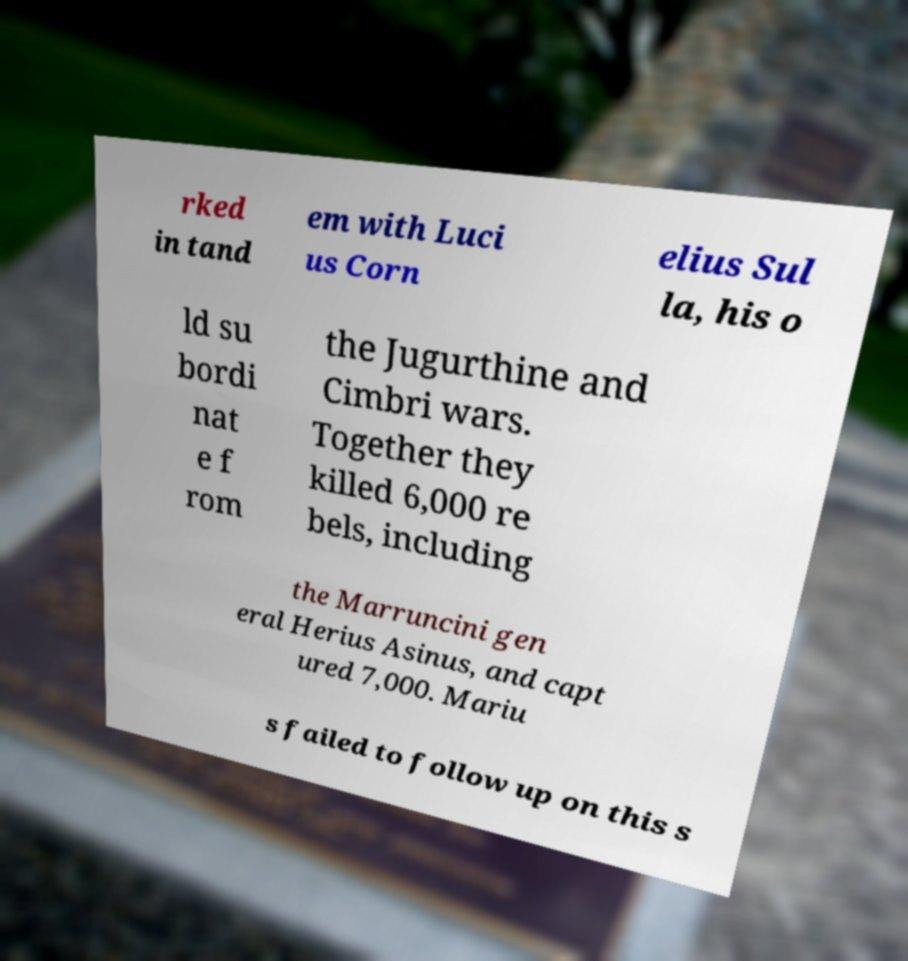Can you read and provide the text displayed in the image?This photo seems to have some interesting text. Can you extract and type it out for me? rked in tand em with Luci us Corn elius Sul la, his o ld su bordi nat e f rom the Jugurthine and Cimbri wars. Together they killed 6,000 re bels, including the Marruncini gen eral Herius Asinus, and capt ured 7,000. Mariu s failed to follow up on this s 